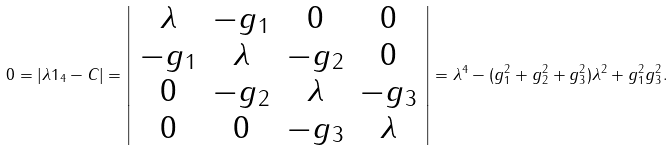Convert formula to latex. <formula><loc_0><loc_0><loc_500><loc_500>0 = | \lambda { 1 } _ { 4 } - C | = \left | \begin{array} { c c c c } \lambda & - g _ { 1 } & 0 & 0 \\ - g _ { 1 } & \lambda & - g _ { 2 } & 0 \\ 0 & - g _ { 2 } & \lambda & - g _ { 3 } \\ 0 & 0 & - g _ { 3 } & \lambda \end{array} \right | = \lambda ^ { 4 } - ( g _ { 1 } ^ { 2 } + g _ { 2 } ^ { 2 } + g _ { 3 } ^ { 2 } ) \lambda ^ { 2 } + g _ { 1 } ^ { 2 } g _ { 3 } ^ { 2 } .</formula> 